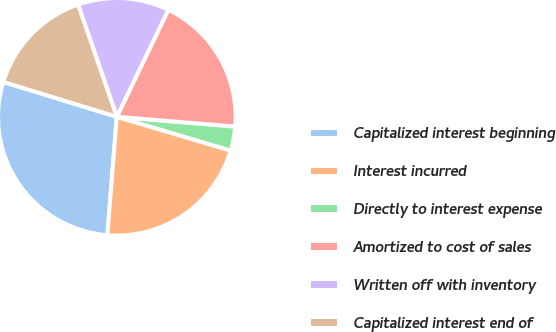Convert chart. <chart><loc_0><loc_0><loc_500><loc_500><pie_chart><fcel>Capitalized interest beginning<fcel>Interest incurred<fcel>Directly to interest expense<fcel>Amortized to cost of sales<fcel>Written off with inventory<fcel>Capitalized interest end of<nl><fcel>28.48%<fcel>21.68%<fcel>3.28%<fcel>19.16%<fcel>12.44%<fcel>14.96%<nl></chart> 